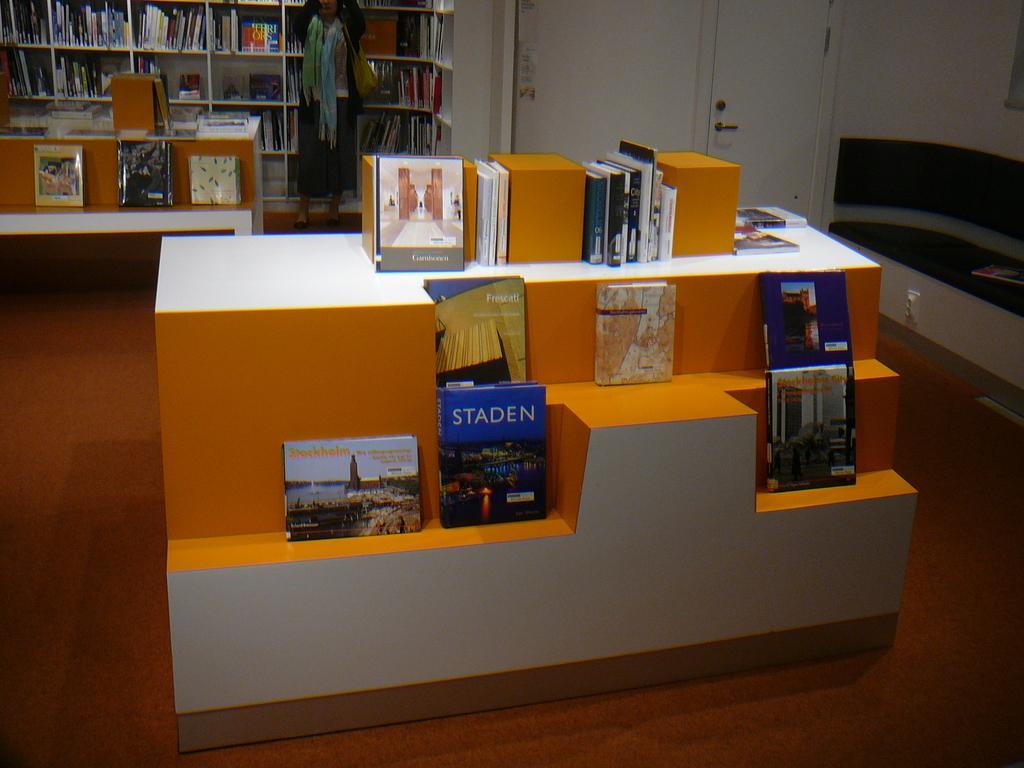Could you give a brief overview of what you see in this image? In this picture we can see books on a stand and in the background we can see a person standing on the floor, books in racks, wall, doors and some objects. 